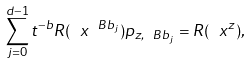Convert formula to latex. <formula><loc_0><loc_0><loc_500><loc_500>\sum _ { j = 0 } ^ { d - 1 } t ^ { - b } R ( \ x ^ { \ B b _ { j } } ) p _ { z , \ B b _ { j } } = R ( \ x ^ { z } ) ,</formula> 